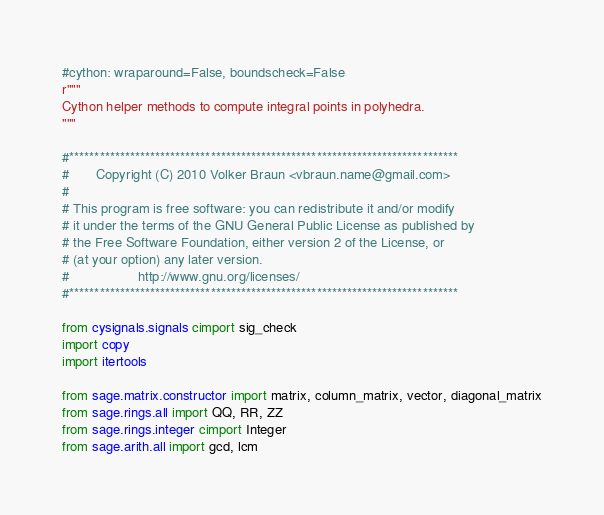Convert code to text. <code><loc_0><loc_0><loc_500><loc_500><_Cython_>#cython: wraparound=False, boundscheck=False
r"""
Cython helper methods to compute integral points in polyhedra.
"""

#*****************************************************************************
#       Copyright (C) 2010 Volker Braun <vbraun.name@gmail.com>
#
# This program is free software: you can redistribute it and/or modify
# it under the terms of the GNU General Public License as published by
# the Free Software Foundation, either version 2 of the License, or
# (at your option) any later version.
#                  http://www.gnu.org/licenses/
#*****************************************************************************

from cysignals.signals cimport sig_check
import copy
import itertools

from sage.matrix.constructor import matrix, column_matrix, vector, diagonal_matrix
from sage.rings.all import QQ, RR, ZZ
from sage.rings.integer cimport Integer
from sage.arith.all import gcd, lcm</code> 